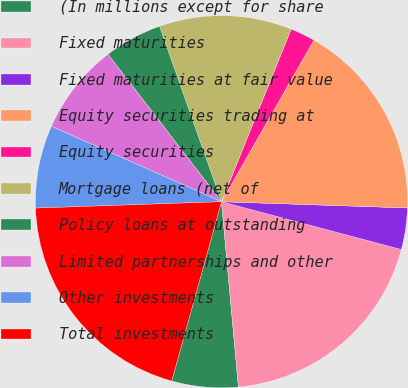Convert chart to OTSL. <chart><loc_0><loc_0><loc_500><loc_500><pie_chart><fcel>(In millions except for share<fcel>Fixed maturities<fcel>Fixed maturities at fair value<fcel>Equity securities trading at<fcel>Equity securities<fcel>Mortgage loans (net of<fcel>Policy loans at outstanding<fcel>Limited partnerships and other<fcel>Other investments<fcel>Total investments<nl><fcel>5.76%<fcel>19.42%<fcel>3.6%<fcel>17.27%<fcel>2.16%<fcel>11.51%<fcel>5.04%<fcel>7.91%<fcel>7.19%<fcel>20.14%<nl></chart> 